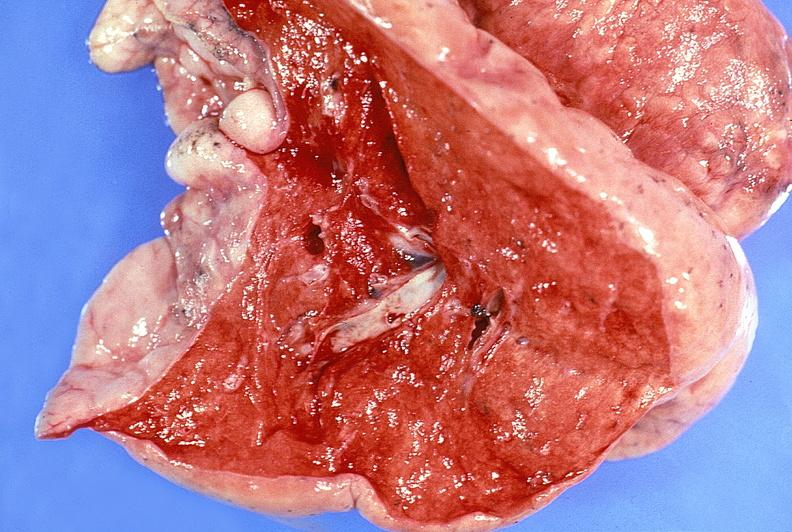does this image show normal lung?
Answer the question using a single word or phrase. Yes 